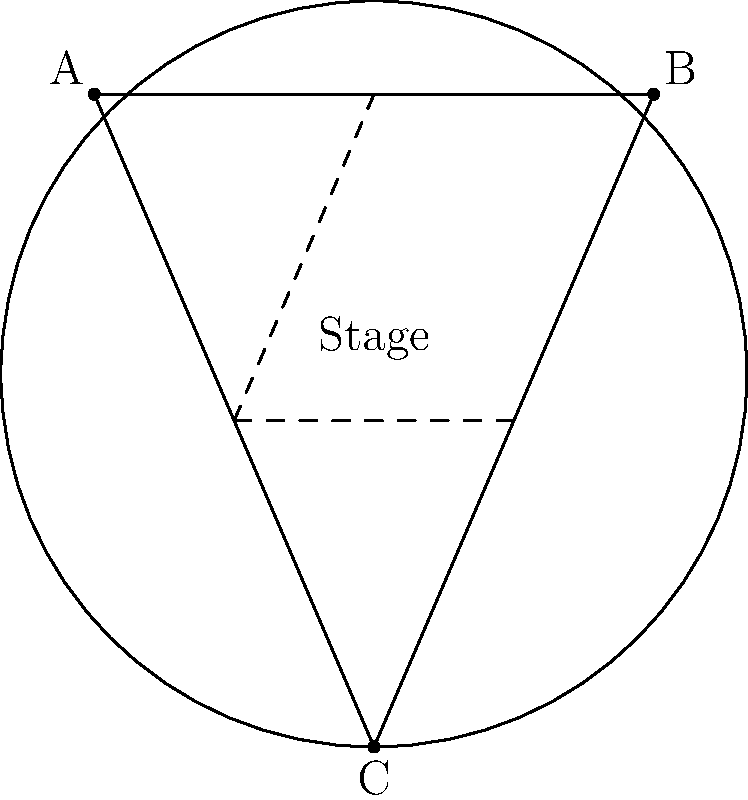As a theater producer, you're designing a set that incorporates hyperbolic geometry to create an illusion of curved space. You decide to use a Poincaré disk model on your circular stage. If you place three actors at points A, B, and C as shown in the diagram, which line segment represents the "shortest path" between two actors in this hyperbolic space? To answer this question, we need to understand the properties of hyperbolic geometry and the Poincaré disk model:

1. In hyperbolic geometry, the "shortest path" between two points is called a geodesic.

2. In the Poincaré disk model, geodesics are represented by either:
   a) Diameters of the disk
   b) Circular arcs that intersect the boundary circle at right angles

3. Looking at the diagram:
   - The line segment A-B is not a diameter and not an arc.
   - The line segments B-C and A-C are not diameters and not arcs.
   - The dashed lines D-F and E-F are portions of diameters.

4. Among the given options, only the dashed lines represent geodesics in this hyperbolic space model.

5. The dashed line D-F, which goes through the center of the disk, is a diameter and thus represents a geodesic.

Therefore, the dashed line D-F represents the "shortest path" between two points (in this case, between the midpoints of sides AB and AC) in this hyperbolic space model.
Answer: The dashed diameter D-F 